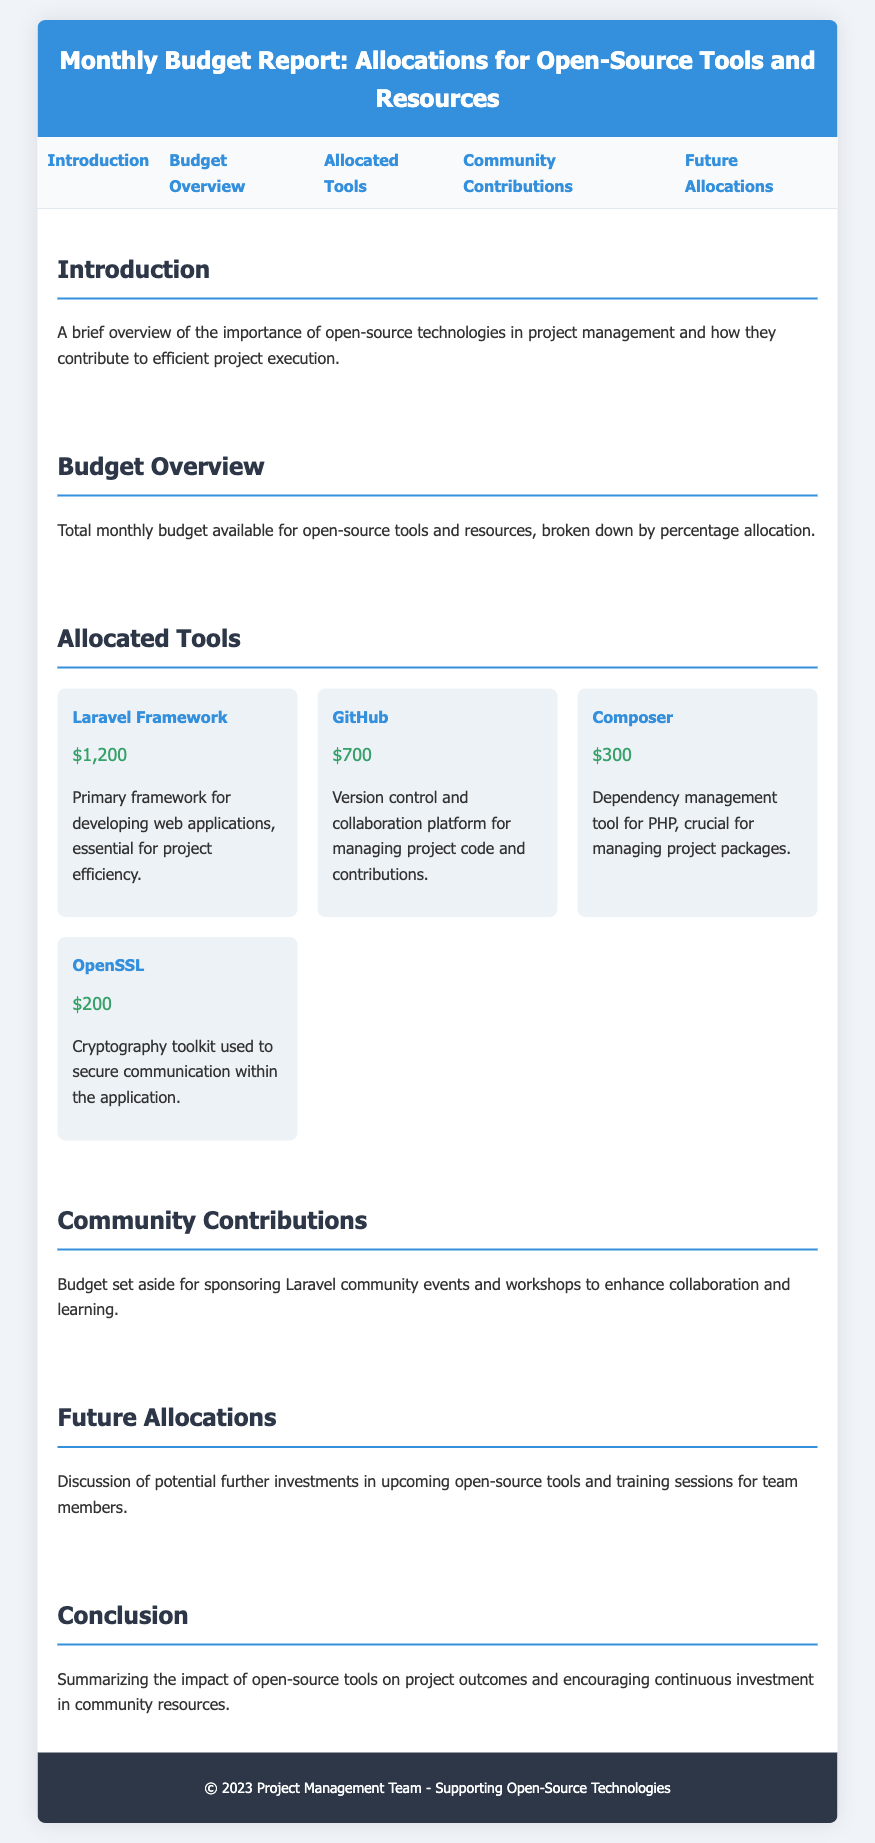What is the title of the report? The title of the report is clearly stated at the top of the document.
Answer: Monthly Budget Report: Allocations for Open-Source Tools and Resources How much is allocated for the Laravel Framework? The document specifically lists the allocation for the Laravel Framework in the allocated tools section.
Answer: $1,200 What percentage of the budget is allocated to community contributions? The document mentions the budget set aside for this purpose, indicating its significance.
Answer: Not mentioned Which tool has the lowest allocation? By comparing the allocations listed in the document, it is evident which tool has the least funding.
Answer: OpenSSL What is the total budget for open-source tools and resources? The total budget is not directly provided but is implied by the allocations of the listed tools.
Answer: Not mentioned How many tools are listed in the allocated tools section? Counting the items under the allocated tools section will give the number of tools.
Answer: 4 What is the emphasis of the introduction section? The introduction highlights the role of open-source technologies in project management.
Answer: Importance of open-source technologies What kind of events does the community contributions section discuss? This section focuses on events and workshops for collaboration and learning in the community.
Answer: Laravel community events and workshops What is mentioned about future investments? The future allocations section discusses potential further investments for upcoming tools and training.
Answer: Further investments in upcoming open-source tools 